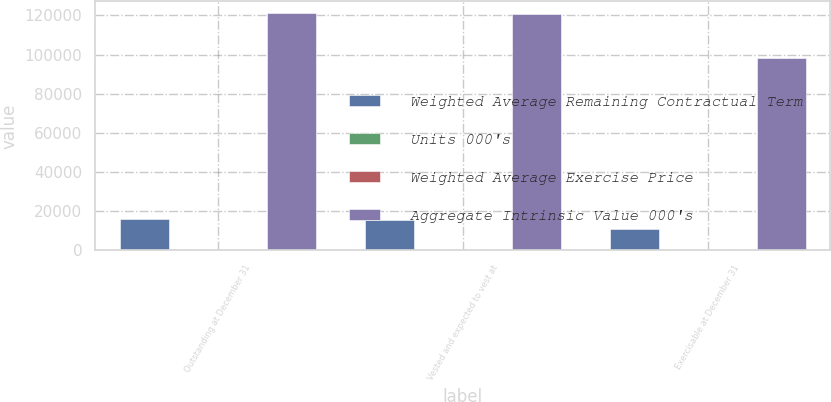<chart> <loc_0><loc_0><loc_500><loc_500><stacked_bar_chart><ecel><fcel>Outstanding at December 31<fcel>Vested and expected to vest at<fcel>Exercisable at December 31<nl><fcel>Weighted Average Remaining Contractual Term<fcel>16176<fcel>15796<fcel>10750<nl><fcel>Units 000's<fcel>15.27<fcel>15.14<fcel>14.1<nl><fcel>Weighted Average Exercise Price<fcel>3.53<fcel>3.47<fcel>2.43<nl><fcel>Aggregate Intrinsic Value 000's<fcel>121194<fcel>120676<fcel>98485<nl></chart> 